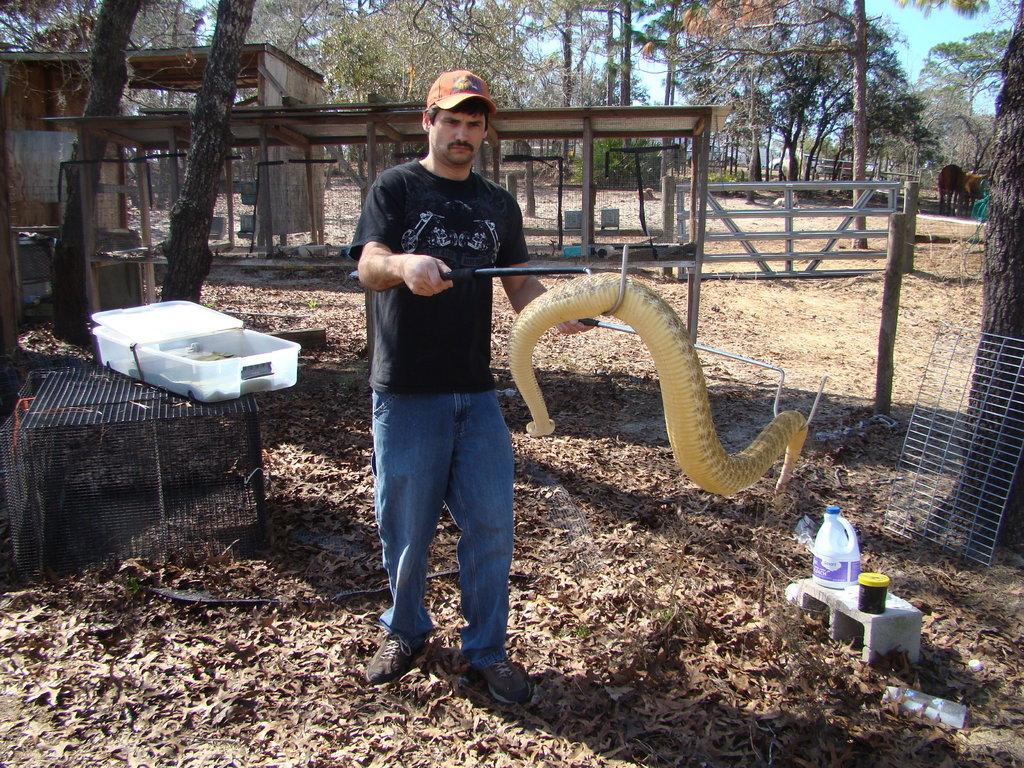What is the main subject of the image? There is a man in the image. What is the man doing in the image? The man is standing and holding a snake in his hands. What can be seen in the background of the image? There are trees and dried leaves in the image. Is there any object present that could be used for storage or transportation? Yes, there is a container in the image. What type of oil is the man teaching in the image? There is no oil or teaching activity present in the image; it features a man holding a snake. 